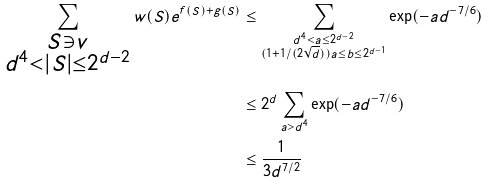<formula> <loc_0><loc_0><loc_500><loc_500>\sum _ { \substack { S \ni v \\ d ^ { 4 } < | S | \leq 2 ^ { d - 2 } } } w ( S ) e ^ { f ( S ) + g ( S ) } & \leq \sum _ { \substack { d ^ { 4 } < a \leq 2 ^ { d - 2 } \\ ( 1 + 1 / ( 2 \sqrt { d } ) ) a \leq b \leq 2 ^ { d - 1 } } } \exp ( - a d ^ { - 7 / 6 } ) \\ & \leq 2 ^ { d } \sum _ { a > d ^ { 4 } } \exp ( - a d ^ { - 7 / 6 } ) \\ & \leq \frac { 1 } { 3 d ^ { 7 / 2 } }</formula> 